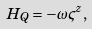<formula> <loc_0><loc_0><loc_500><loc_500>H _ { Q } = - \omega \varsigma ^ { z } ,</formula> 